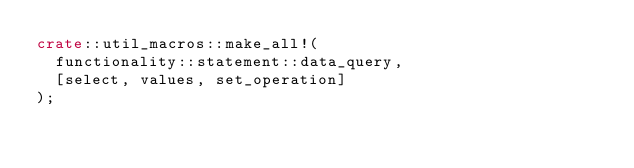<code> <loc_0><loc_0><loc_500><loc_500><_Rust_>crate::util_macros::make_all!(
	functionality::statement::data_query,
	[select, values, set_operation]
);
</code> 